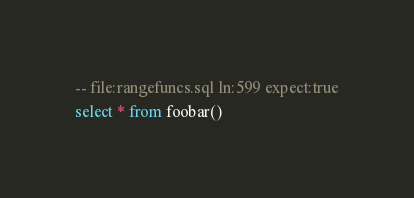<code> <loc_0><loc_0><loc_500><loc_500><_SQL_>-- file:rangefuncs.sql ln:599 expect:true
select * from foobar()
</code> 